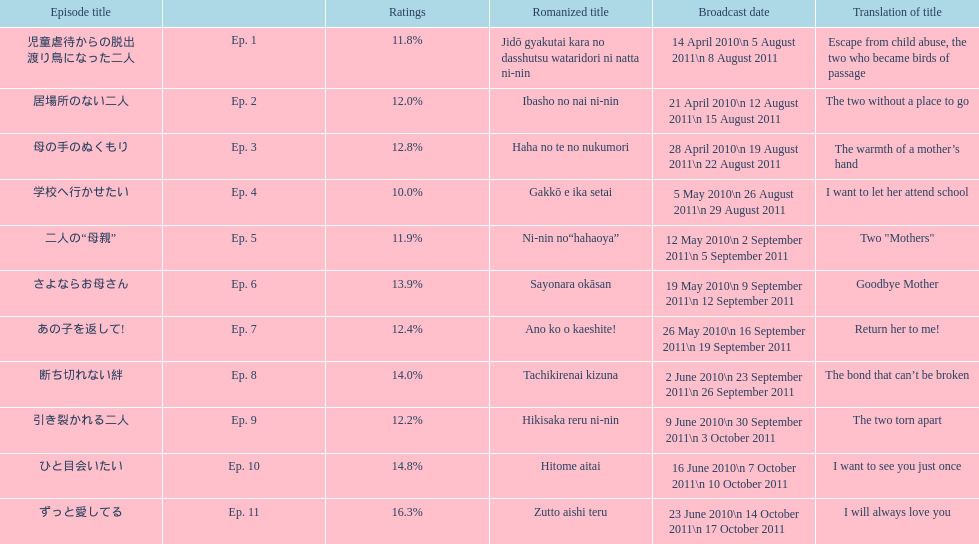What was the name of the next episode after goodbye mother? あの子を返して!. 